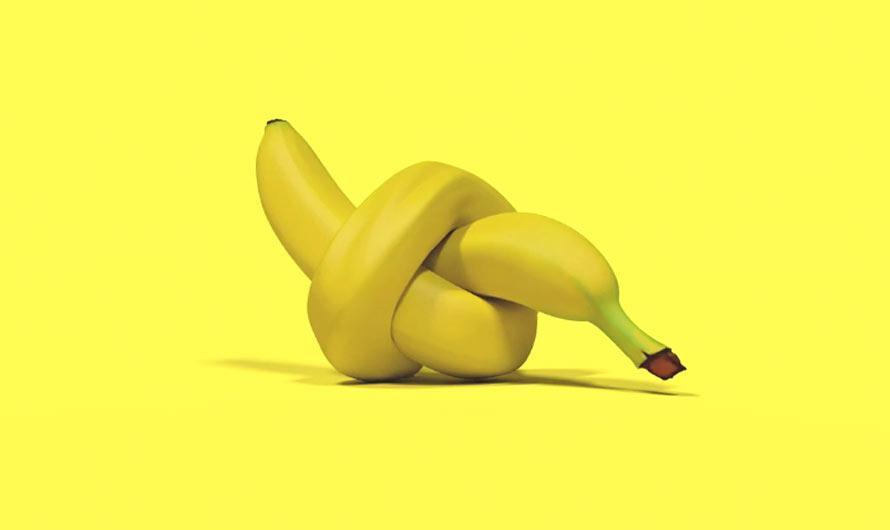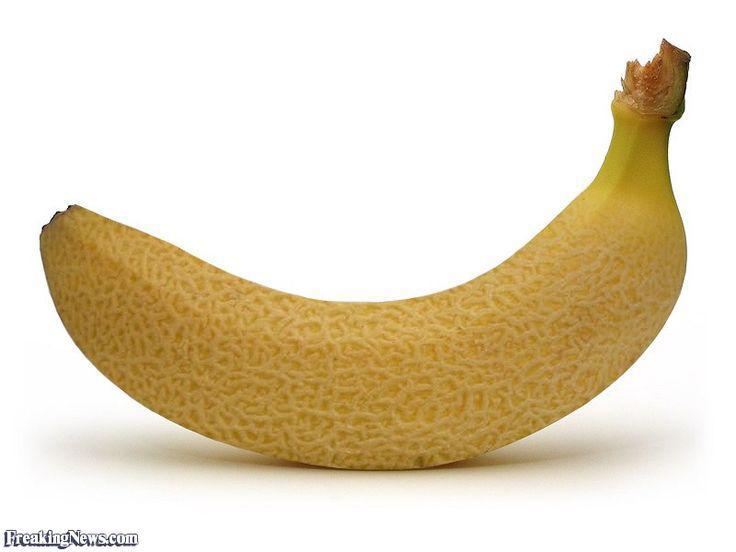The first image is the image on the left, the second image is the image on the right. Analyze the images presented: Is the assertion "There are real bananas in one of the images." valid? Answer yes or no. No. The first image is the image on the left, the second image is the image on the right. Assess this claim about the two images: "One of the images features a vegetable turning in to a banana.". Correct or not? Answer yes or no. No. 